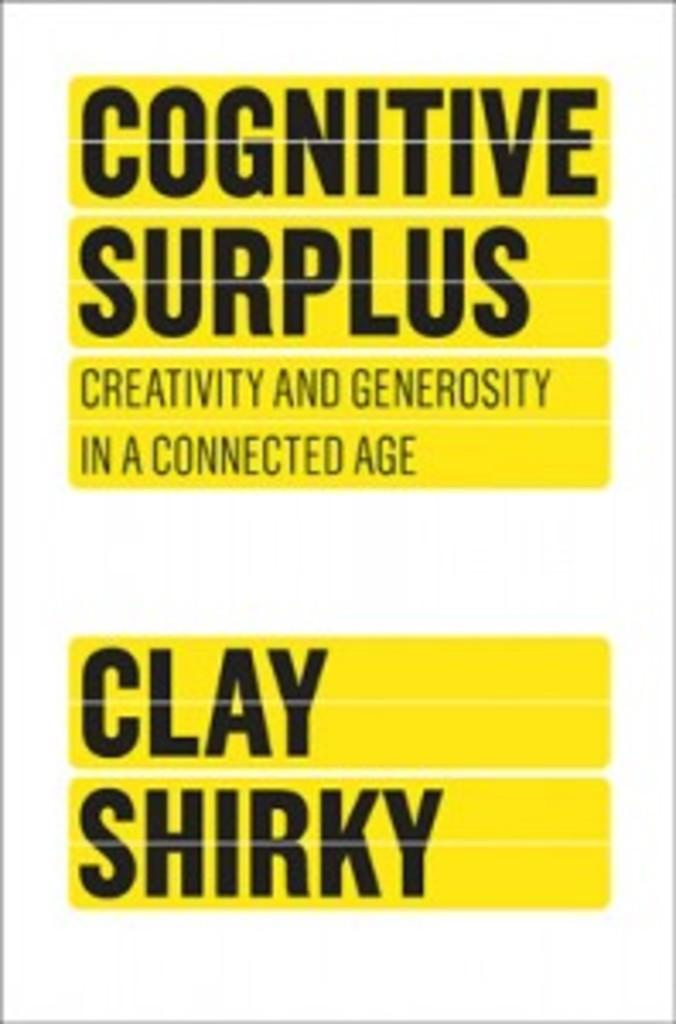<image>
Render a clear and concise summary of the photo. A book called Cognitive Surplus by Clay Shirky 